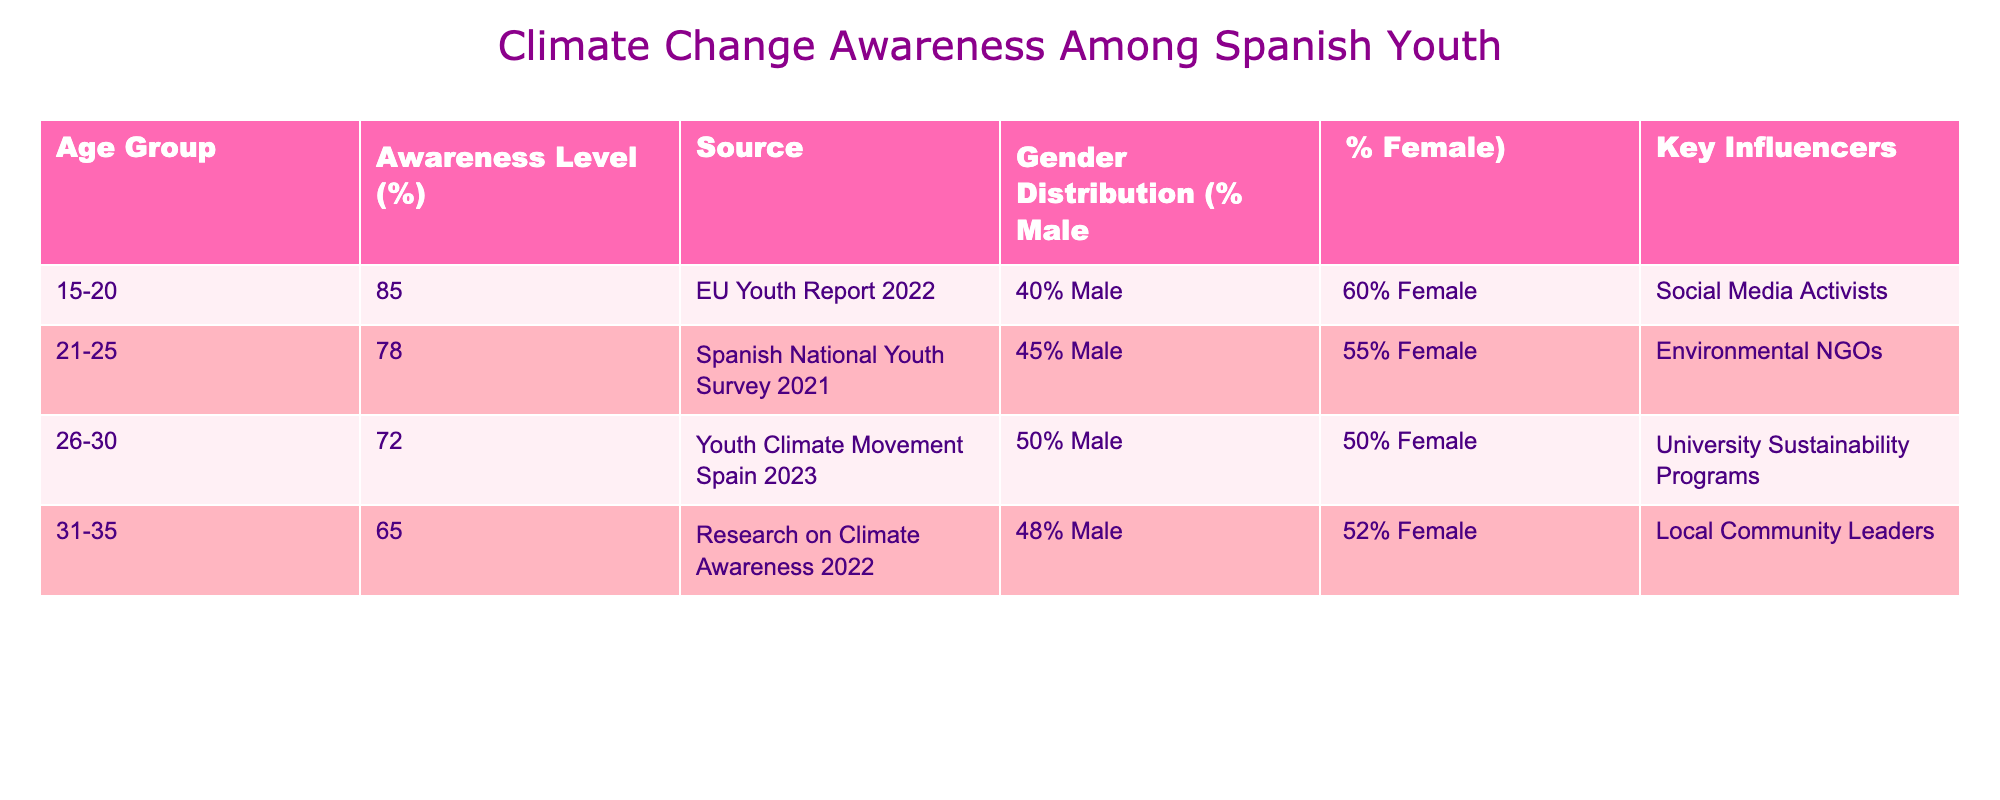What is the awareness level of the 15-20 age group regarding climate change? The table indicates that the awareness level for the age group 15-20 is 85%. This can be found directly in the "Awareness Level (%)" column corresponding to the "15-20" age group.
Answer: 85% Which age group has the lowest awareness level of climate change? The table shows that the age group 31-35 has the lowest awareness level of 65%. By comparing all the values in the "Awareness Level (%)" column, 65% is indeed the minimum.
Answer: 31-35 What percentage of the 21-25 age group is male? According to the data, the gender distribution for the 21-25 age group specifies that 45% are male. This information is extracted from the "Gender Distribution" column for that specific age group.
Answer: 45% Calculate the average awareness level of all age groups represented in the table. To compute the average awareness level, we first add up the percentages: 85 + 78 + 72 + 65 = 300. Then, we divide the total (300) by the number of age groups (4) to find the average, which is 300 / 4 = 75.
Answer: 75 Is the awareness level of the 26-30 age group higher than that of the 31-35 age group? Yes, the awareness level of the 26-30 age group is 72%, while the 31-35 age group is at 65%. Thus, 72% is indeed higher than 65%.
Answer: Yes What key influencers are associated with the 15-20 age group? The table specifies that "Social Media Activists" are indicated as the key influencers for the 15-20 age group. We can read this directly from the "Key Influencers" column related to that specific age group.
Answer: Social Media Activists How does the gender distribution compare between the 26-30 and 21-25 age groups? For the 26-30 age group, the gender distribution is 50% Male and 50% Female, while for the 21-25 age group, it is 45% Male and 55% Female. Comparing these, the 26-30 age group has an equal distribution, whereas the 21-25 age group has a slightly higher percentage of females than males.
Answer: 26-30 is equal; 21-25 has more females What is the difference in awareness levels between the 15-20 and 31-35 age groups? The awareness level for the 15-20 age group is 85% and for the 31-35 age group, it is 65%. To find the difference, we subtract: 85 - 65 = 20. Thus, the difference in awareness levels is 20%.
Answer: 20% 